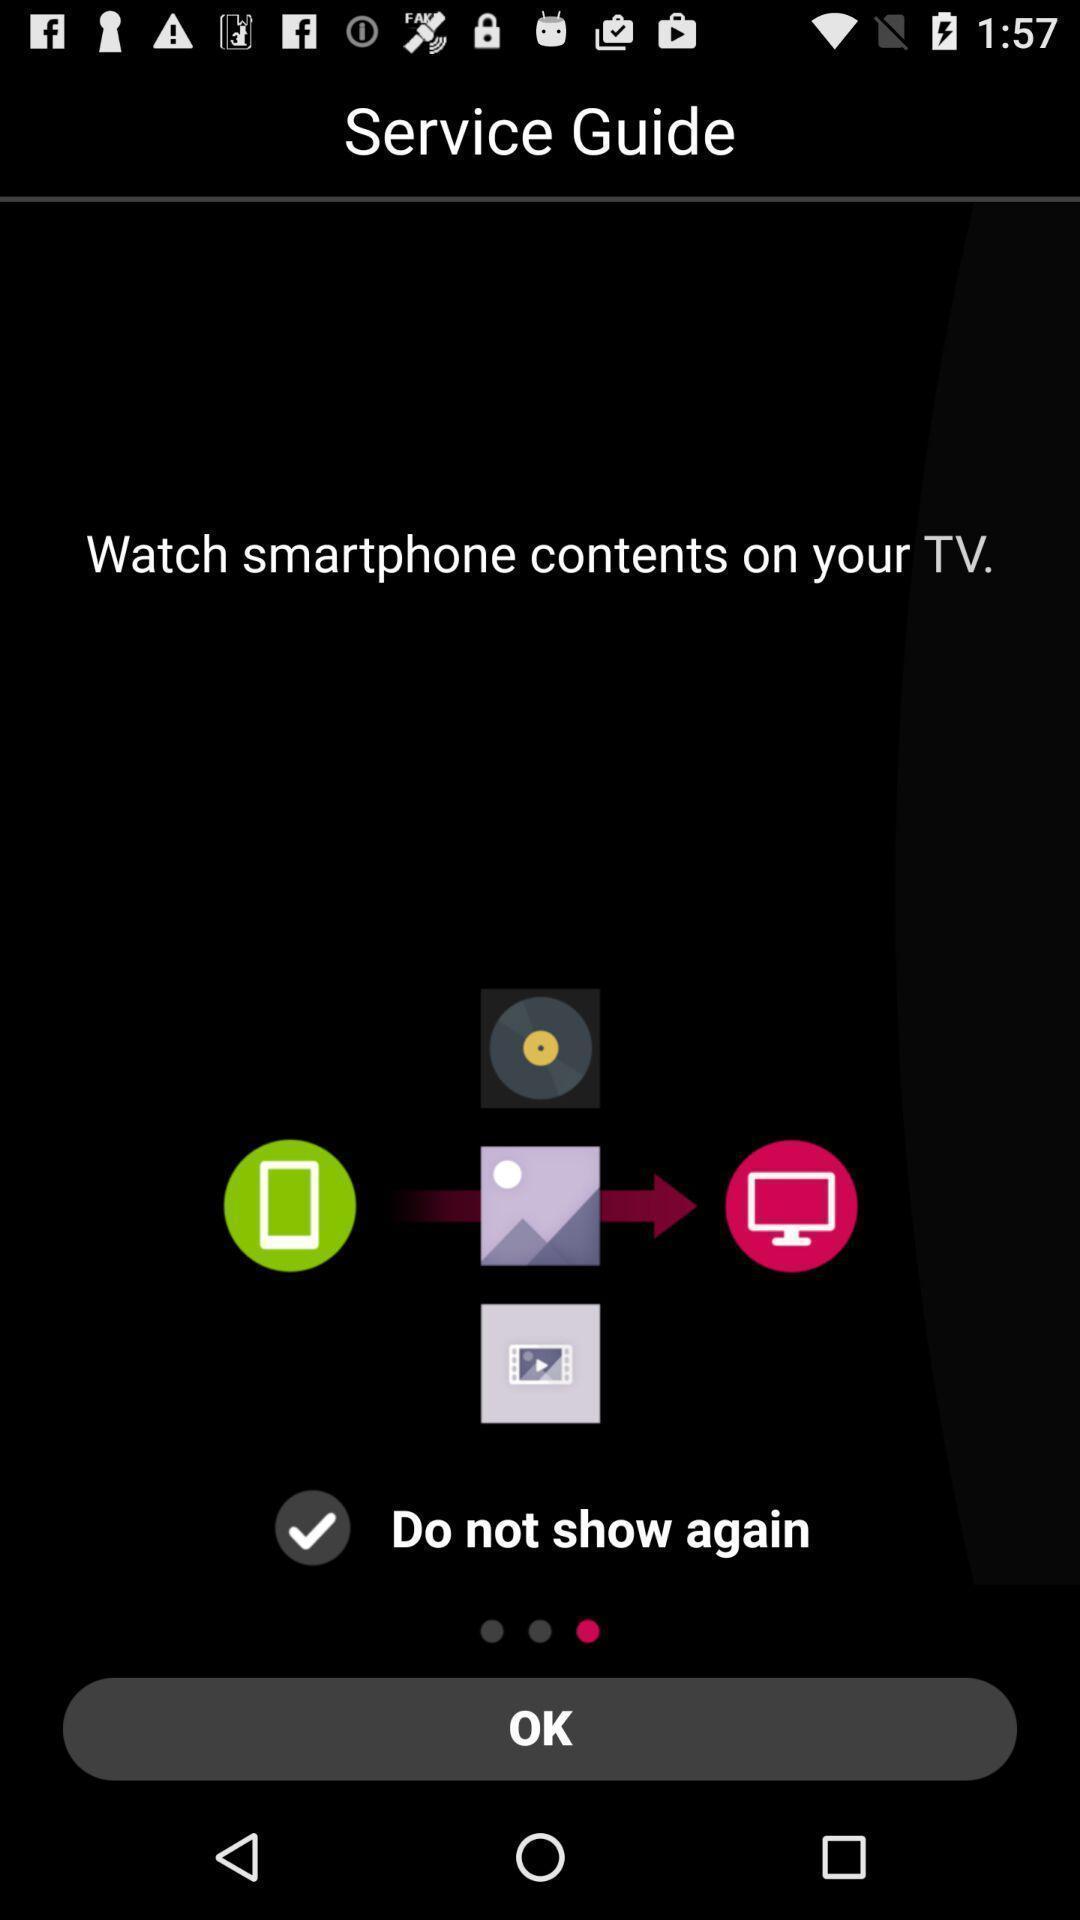Explain what's happening in this screen capture. Window displaying a guide page. 